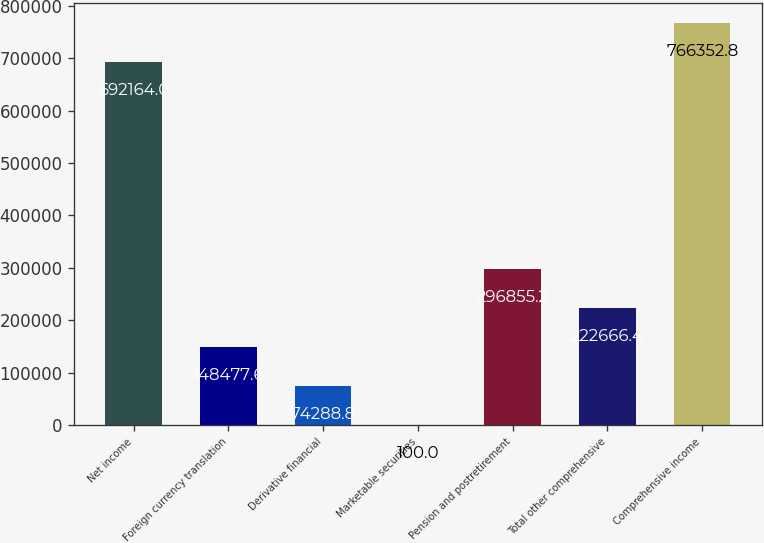<chart> <loc_0><loc_0><loc_500><loc_500><bar_chart><fcel>Net income<fcel>Foreign currency translation<fcel>Derivative financial<fcel>Marketable securities<fcel>Pension and postretirement<fcel>Total other comprehensive<fcel>Comprehensive income<nl><fcel>692164<fcel>148478<fcel>74288.8<fcel>100<fcel>296855<fcel>222666<fcel>766353<nl></chart> 